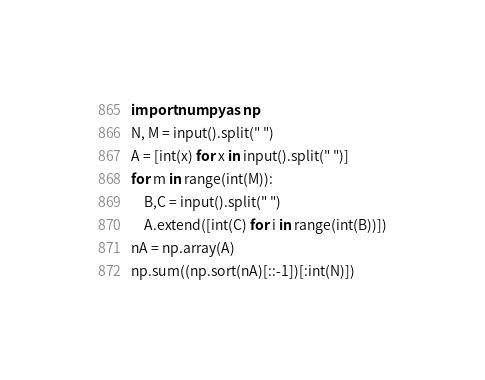Convert code to text. <code><loc_0><loc_0><loc_500><loc_500><_Python_>import numpy as np
N, M = input().split(" ")
A = [int(x) for x in input().split(" ")]
for m in range(int(M)):
    B,C = input().split(" ")
    A.extend([int(C) for i in range(int(B))])
nA = np.array(A)
np.sum((np.sort(nA)[::-1])[:int(N)])</code> 